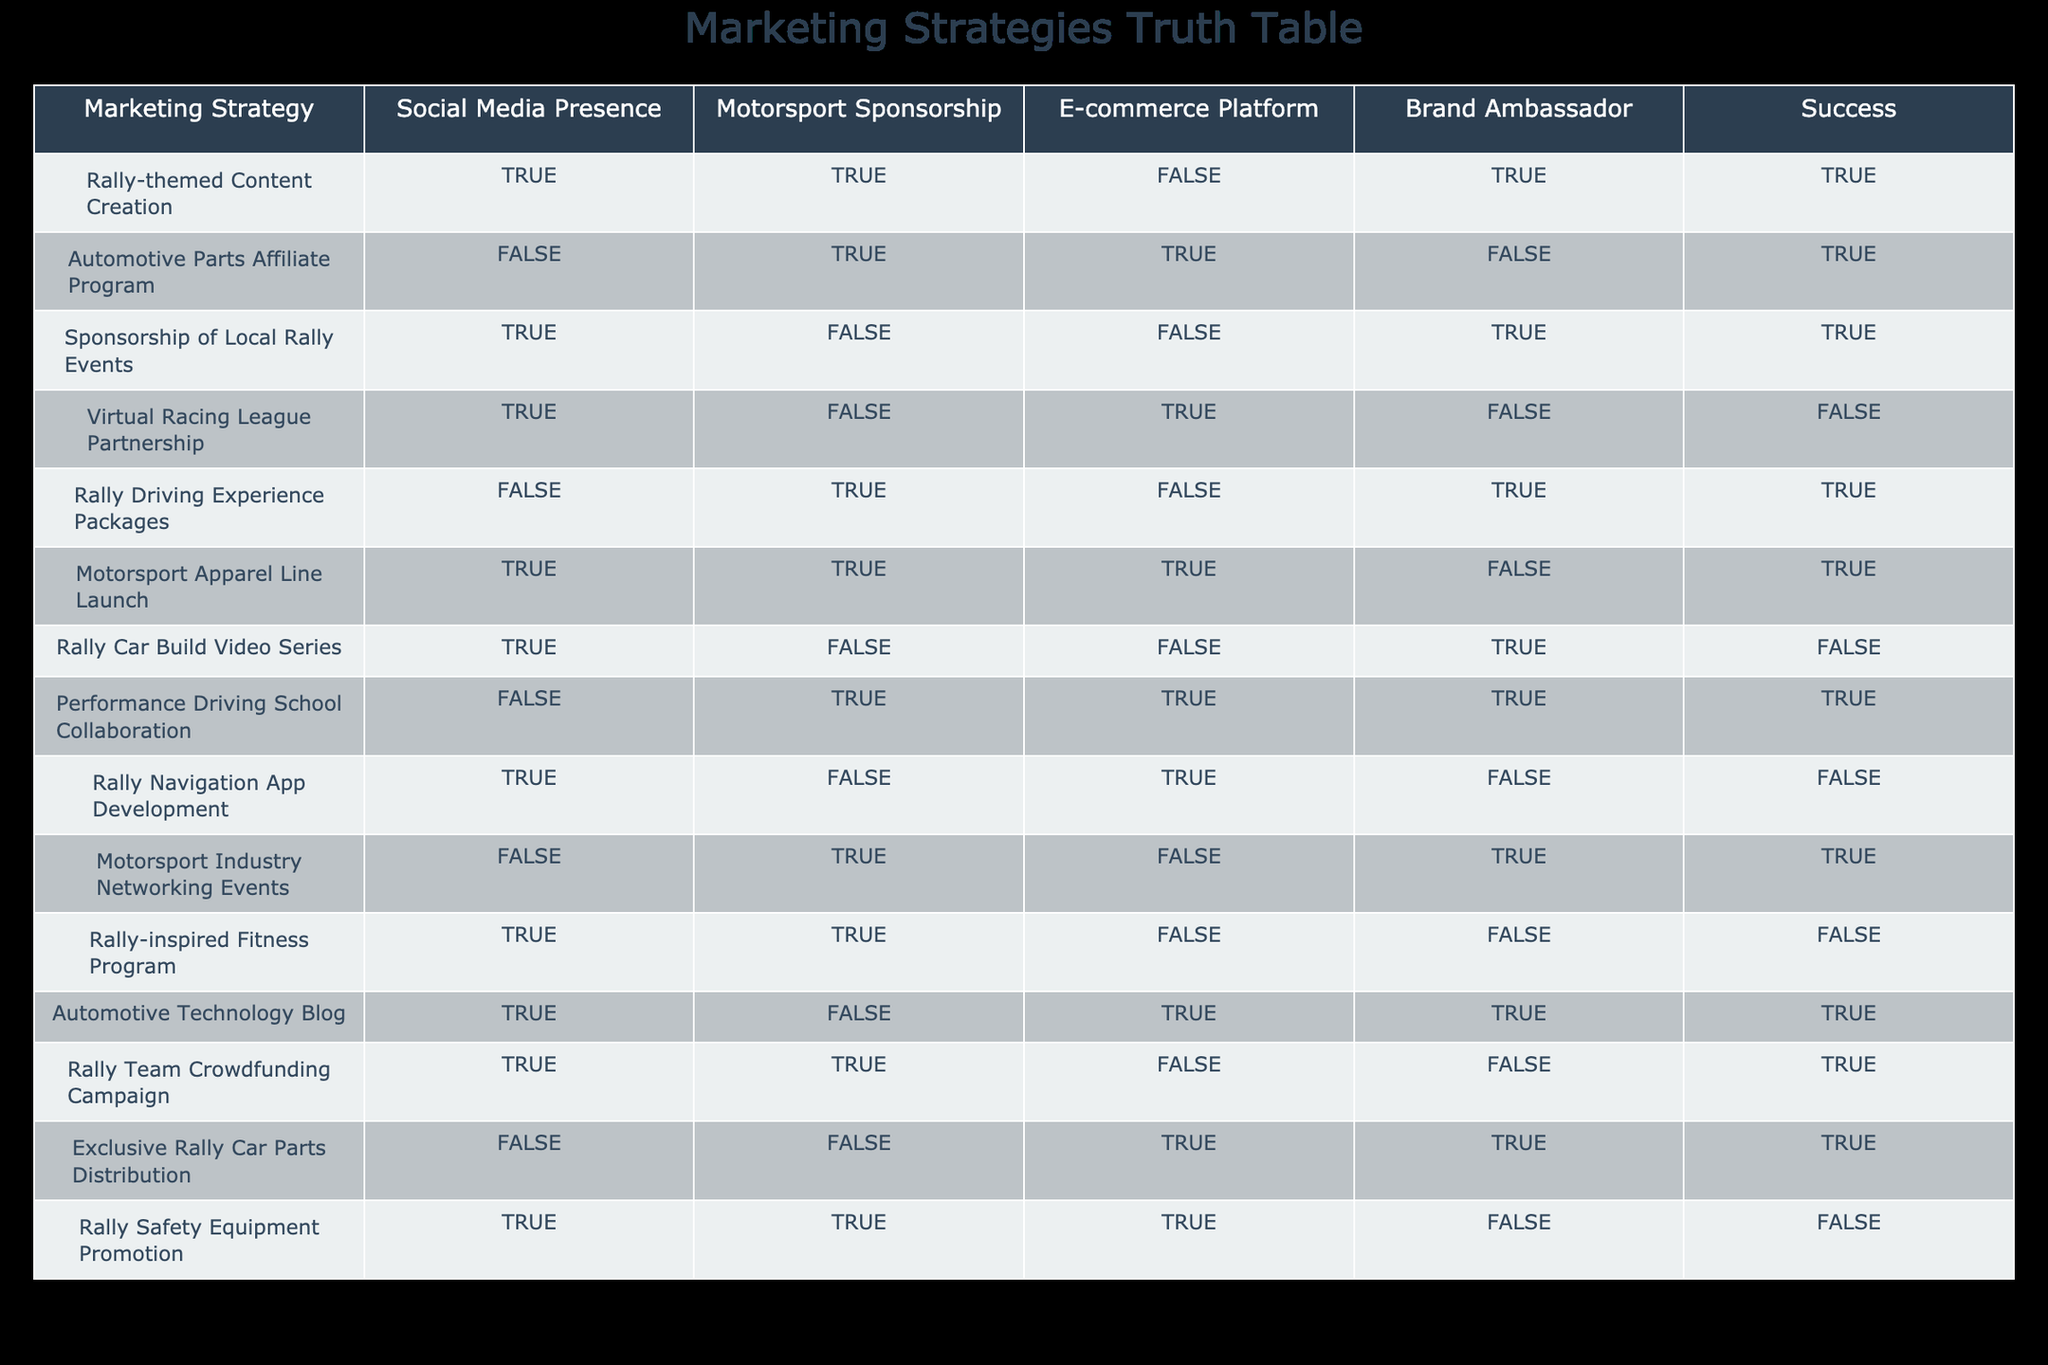What is the success rate for strategies that include social media presence? There are 5 strategies with a social media presence, and out of those, 3 are marked as successful. To find the success rate, we calculate (3 successful strategies / 5 total strategies) = 0.6 or 60%.
Answer: 60% Which marketing strategy combines e-commerce and motorsport sponsorship? The only strategy listed that combines both e-commerce and motorsport sponsorship is the "Automotive Parts Affiliate Program." The other rows either include one without the other or neither.
Answer: Automotive Parts Affiliate Program Is there any strategy that has a successful outcome with no brand ambassador involved? Looking at the table, there are successful strategies: "Automotive Parts Affiliate Program," "Sponsorship of Local Rally Events," "Rally Driving Experience Packages," and "Performance Driving School Collaboration," all of which do not have a brand ambassador. Therefore, yes, there are several such strategies.
Answer: Yes What is the total number of marketing strategies that incorporate both sponsorship and social media presence? We count the strategies that have both "TRUE" for Motorsport Sponsorship and "TRUE" for Social Media Presence. The strategies that fit this criteria are: "Rally-themed Content Creation," "Motorsport Apparel Line Launch," and "Rally Team Crowdfunding Campaign." There are 3 such strategies in total.
Answer: 3 If we consider only the successful strategies, how many have a focus on content creation (such as videos or blogs)? The successful strategies containing a content focus are "Rally-themed Content Creation," "Automotive Technology Blog," which gives us two successful strategies focused specifically on content creation.
Answer: 2 Is there a direct correlation between offering rally experience packages and successful outcomes? To analyze, we need to locate the "Rally Driving Experience Packages." It is successful, but we need to check others in the table. Other factors like social media presence or sponsorship terms might also correlate but aren't specifically outlined here. Therefore, based only on the data provided, we cannot definitively state a correlation exists; it's a single data point.
Answer: No Are there more strategies focused on sponsorship compared to those on e-commerce platforms? We can count the strategies focused on motorsport sponsorship (6 strategies total) and those focused on e-commerce platforms (4 strategies total). Thus, there are indeed more sponsorship-focused strategies than those using e-commerce platforms.
Answer: Yes What percentage of strategies are successful when they include a brand ambassador? Strategies with a brand ambassador are: "Rally-themed Content Creation," "Rally Driving Experience Packages," "Performance Driving School Collaboration," and "Rally Team Crowdfunding Campaign," totaling 4 strategies. Out of these, 2 are marked as successful. The percentage is calculated as (2 successful/4 total) x 100 = 50%.
Answer: 50% Which marketing strategy has the highest number of components (social media, sponsorship, e-commerce, brand ambassador) and what is its success status? The strategy with the most components is "Motorsport Apparel Line Launch," which includes social media presence, sponsorship, and e-commerce but lacks a brand ambassador. Its success status is marked as successful.
Answer: Motorsport Apparel Line Launch, Successful 